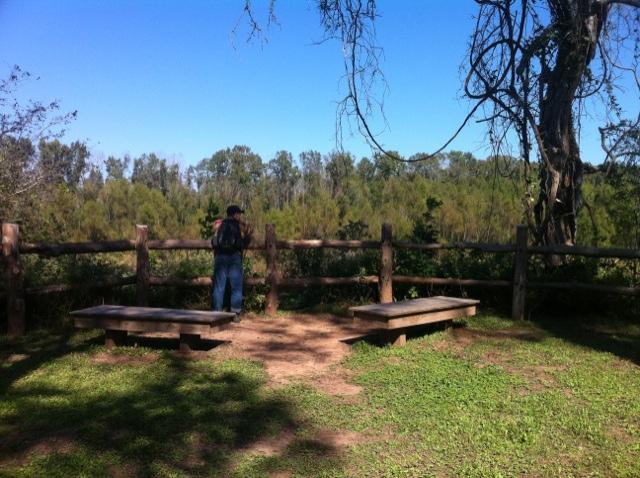Sunny or overcast?
Short answer required. Sunny. Is this person a hiker?
Quick response, please. Yes. Is this a public park?
Be succinct. Yes. 